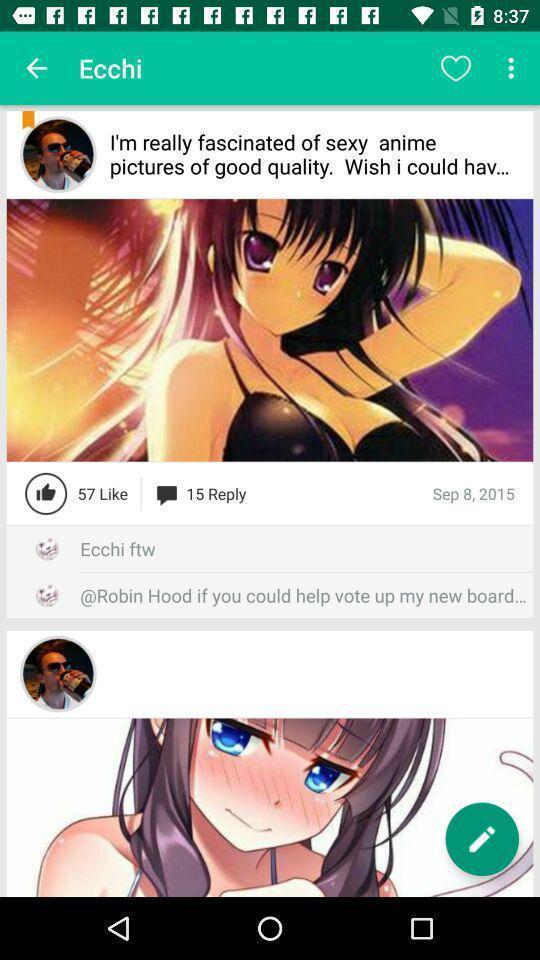Explain the elements present in this screenshot. Various feed displayed. 